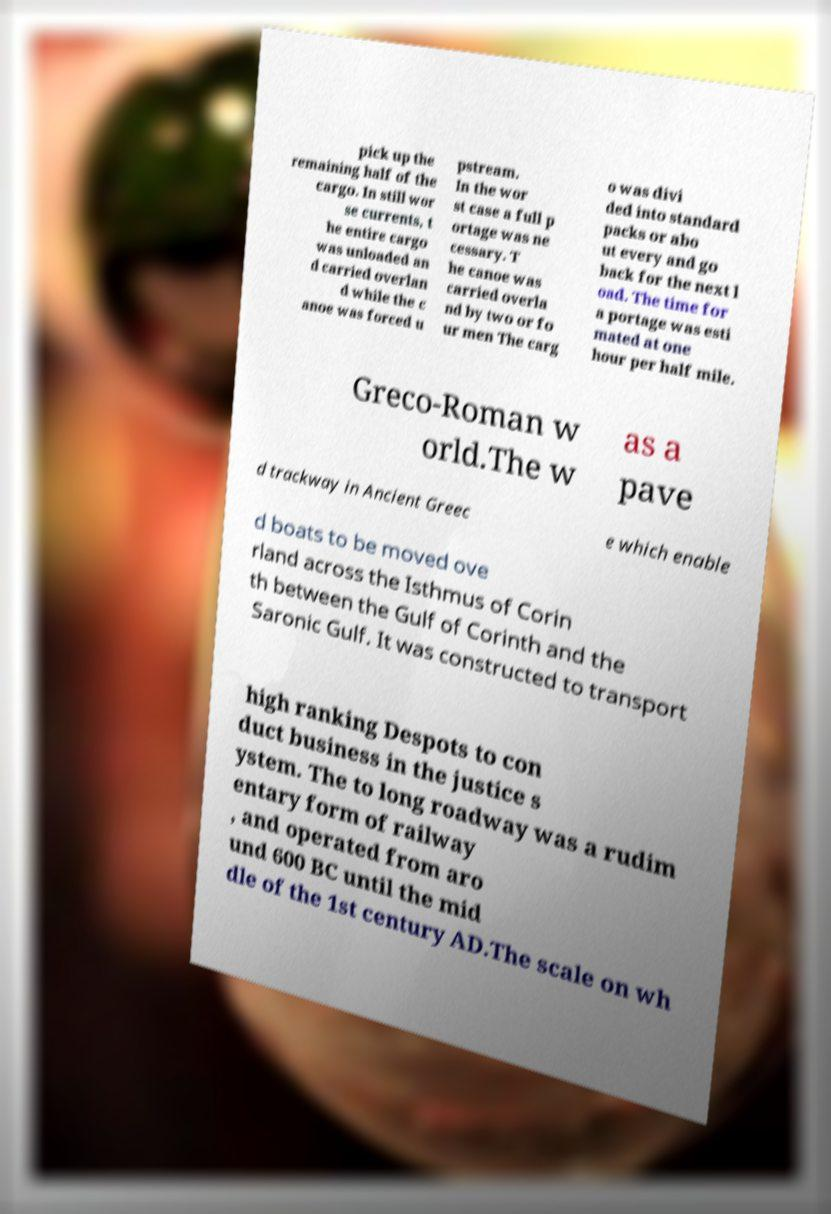Please read and relay the text visible in this image. What does it say? pick up the remaining half of the cargo. In still wor se currents, t he entire cargo was unloaded an d carried overlan d while the c anoe was forced u pstream. In the wor st case a full p ortage was ne cessary. T he canoe was carried overla nd by two or fo ur men The carg o was divi ded into standard packs or abo ut every and go back for the next l oad. The time for a portage was esti mated at one hour per half mile. Greco-Roman w orld.The w as a pave d trackway in Ancient Greec e which enable d boats to be moved ove rland across the Isthmus of Corin th between the Gulf of Corinth and the Saronic Gulf. It was constructed to transport high ranking Despots to con duct business in the justice s ystem. The to long roadway was a rudim entary form of railway , and operated from aro und 600 BC until the mid dle of the 1st century AD.The scale on wh 